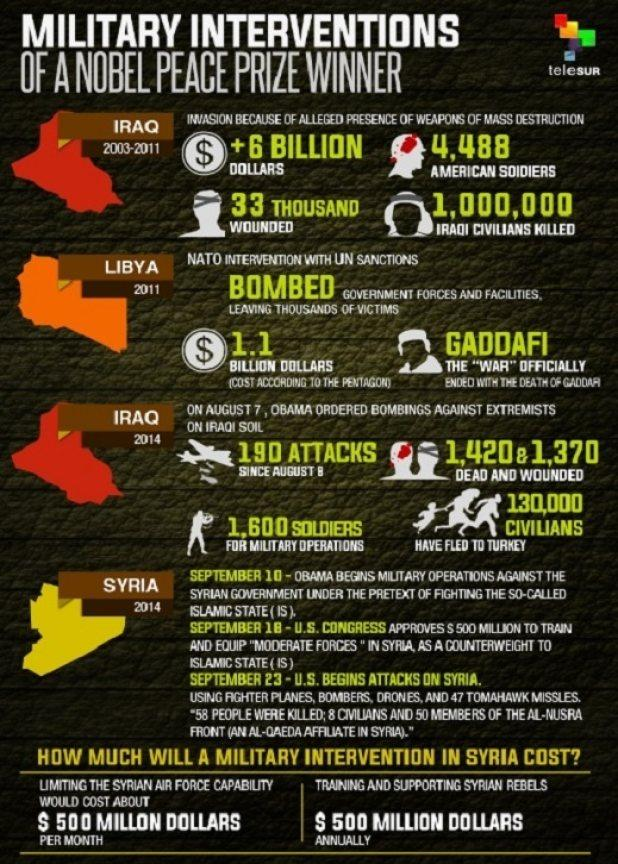Draw attention to some important aspects in this diagram. In 2014, a total of 1,600 soldiers were deployed for military operations in Iraq. In 2014, the bombing against extremists in Iraq resulted in a total of 2,790 deaths and wounded people. During the 2003-2011 Iraq invasion, a total of 4,488 American soldiers were killed. 